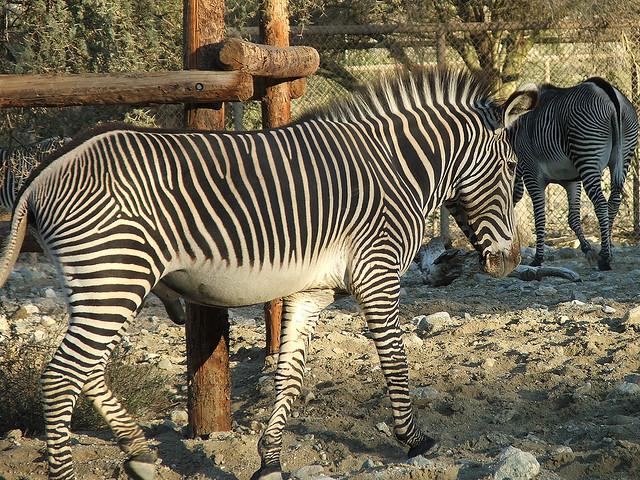What is cast?
Concise answer only. Shadow. Is this zebra a female?
Write a very short answer. No. What gender is this Zebra?
Quick response, please. Male. 